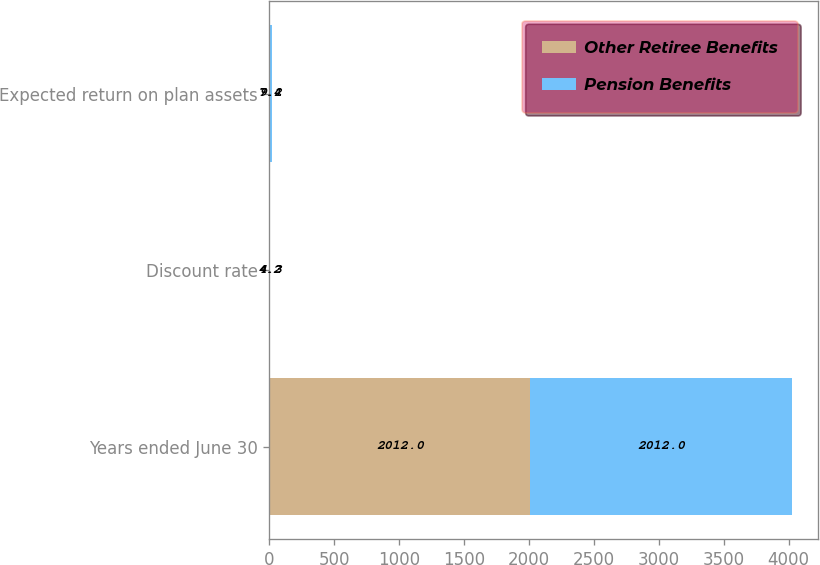Convert chart. <chart><loc_0><loc_0><loc_500><loc_500><stacked_bar_chart><ecel><fcel>Years ended June 30<fcel>Discount rate<fcel>Expected return on plan assets<nl><fcel>Other Retiree Benefits<fcel>2012<fcel>4.2<fcel>7.4<nl><fcel>Pension Benefits<fcel>2012<fcel>4.3<fcel>9.2<nl></chart> 